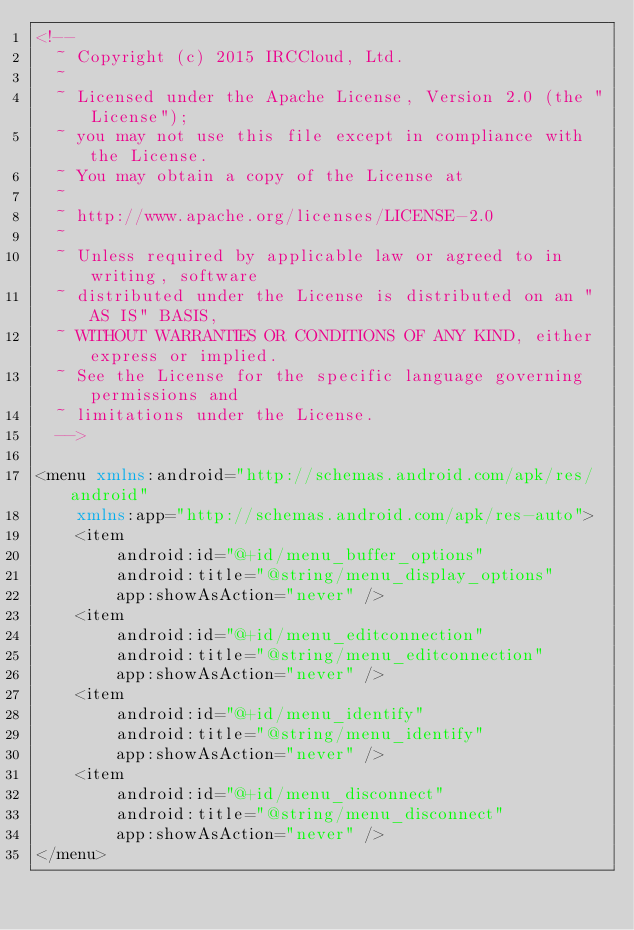<code> <loc_0><loc_0><loc_500><loc_500><_XML_><!--
  ~ Copyright (c) 2015 IRCCloud, Ltd.
  ~
  ~ Licensed under the Apache License, Version 2.0 (the "License");
  ~ you may not use this file except in compliance with the License.
  ~ You may obtain a copy of the License at
  ~
  ~ http://www.apache.org/licenses/LICENSE-2.0
  ~
  ~ Unless required by applicable law or agreed to in writing, software
  ~ distributed under the License is distributed on an "AS IS" BASIS,
  ~ WITHOUT WARRANTIES OR CONDITIONS OF ANY KIND, either express or implied.
  ~ See the License for the specific language governing permissions and
  ~ limitations under the License.
  -->

<menu xmlns:android="http://schemas.android.com/apk/res/android"
    xmlns:app="http://schemas.android.com/apk/res-auto">
    <item
        android:id="@+id/menu_buffer_options"
        android:title="@string/menu_display_options"
        app:showAsAction="never" />
    <item
        android:id="@+id/menu_editconnection"
        android:title="@string/menu_editconnection"
        app:showAsAction="never" />
    <item
        android:id="@+id/menu_identify"
        android:title="@string/menu_identify"
        app:showAsAction="never" />
    <item
        android:id="@+id/menu_disconnect"
        android:title="@string/menu_disconnect"
        app:showAsAction="never" />
</menu>
</code> 